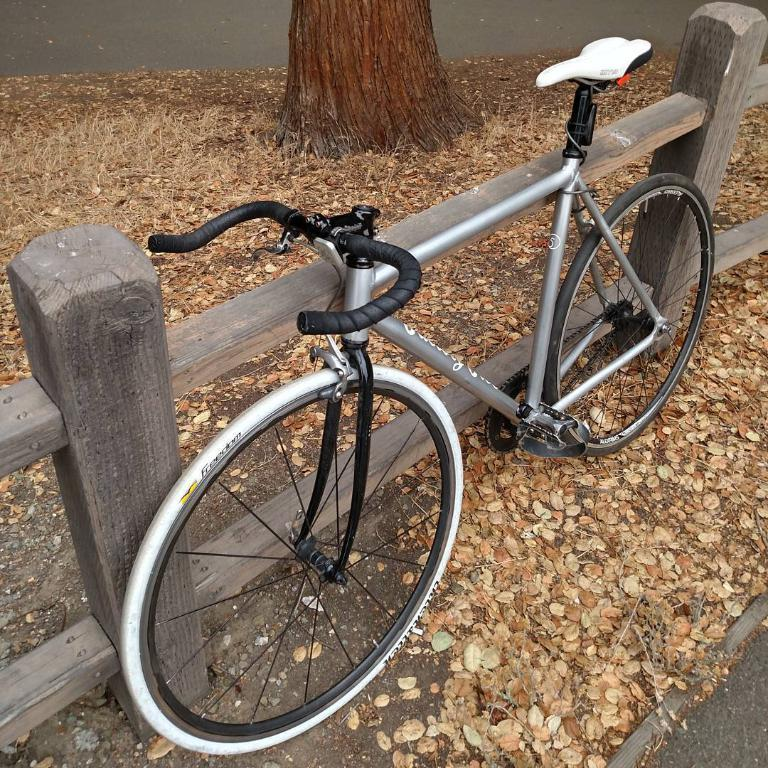What is the main object in the image? There is a bicycle in the image. What is the state of the bicycle in the image? The bicycle is parked. What type of barrier can be seen in the image? There is a wooden fence in the image. What is present on the ground in the image? Dried leaves are lying on the ground. What part of a tree is visible in the image? There is a tree trunk visible at the top of the image. How many cakes are being sold at the bicycle shop in the image? There is no mention of a bicycle shop or cakes in the image. Is there a ring visible in the image? There is no ring present in the image. 